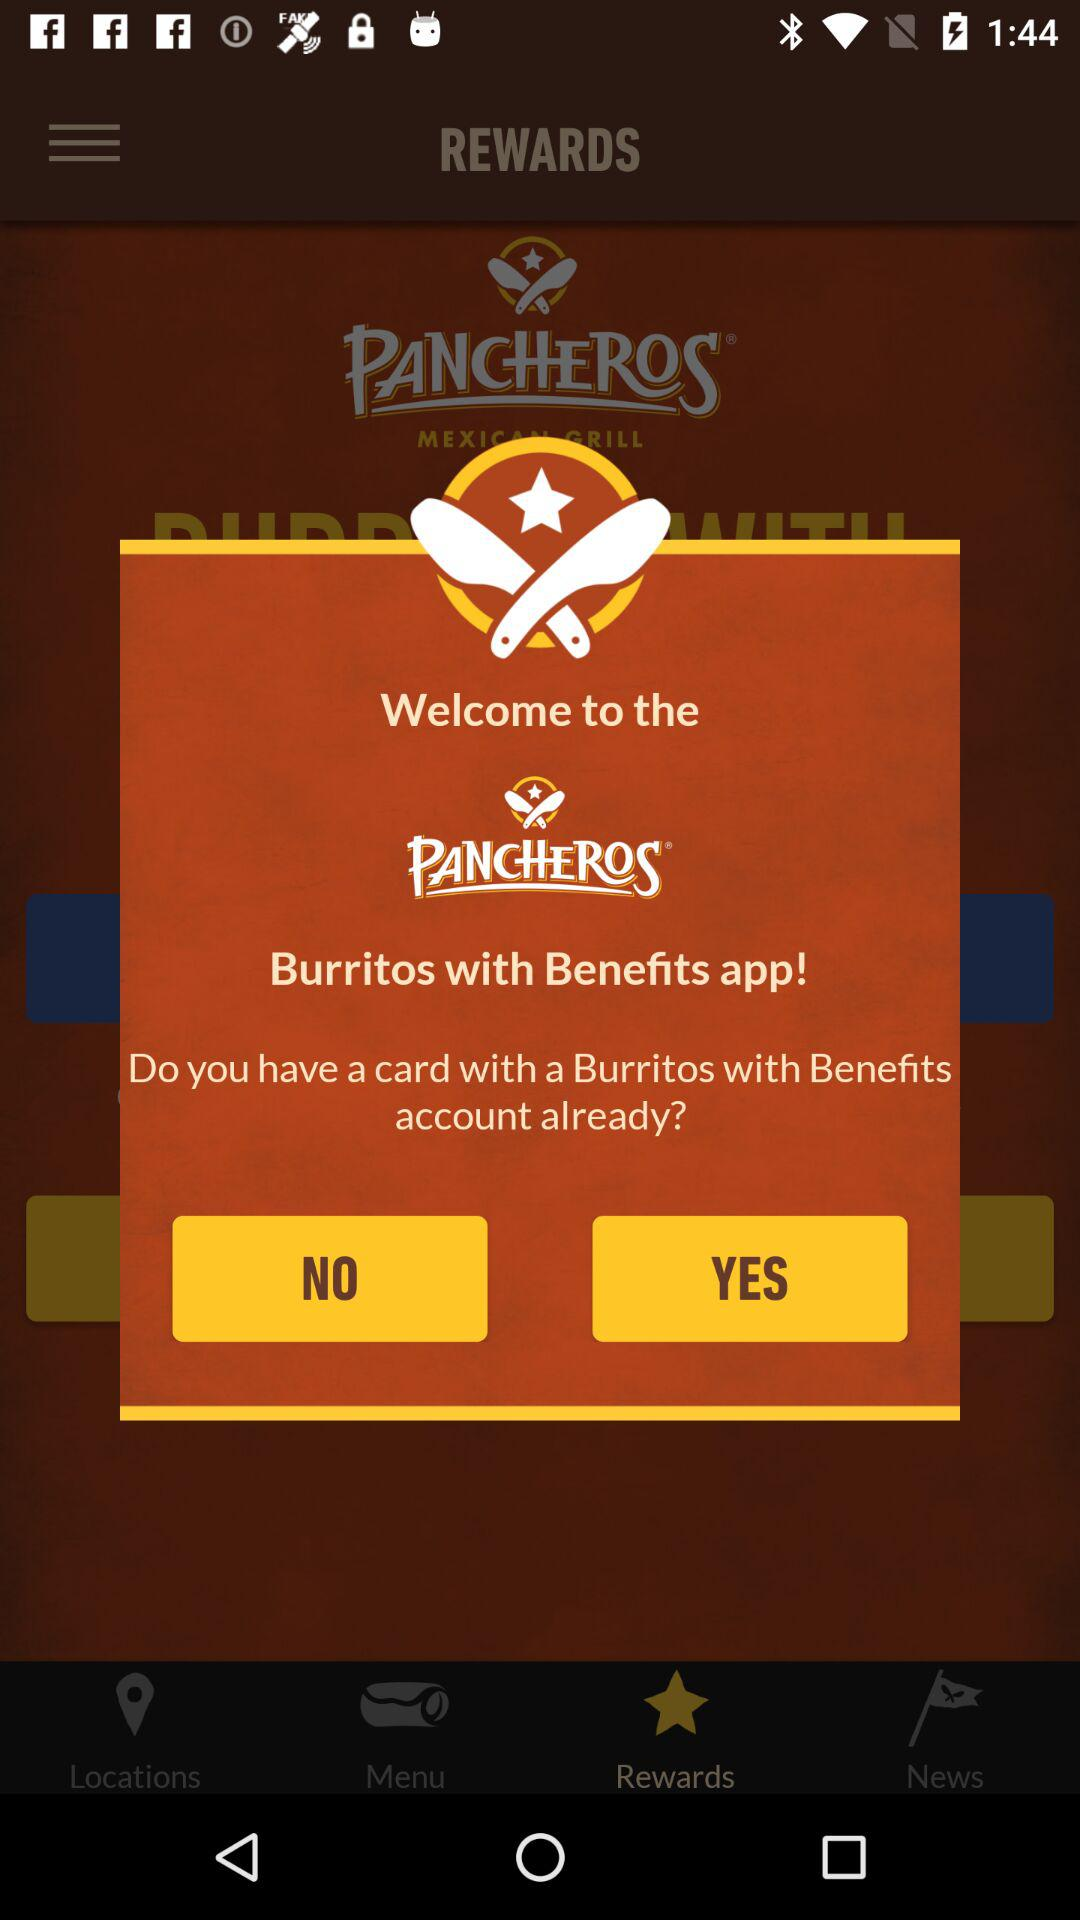What is the application name? The application name is "PANCHEROS". 